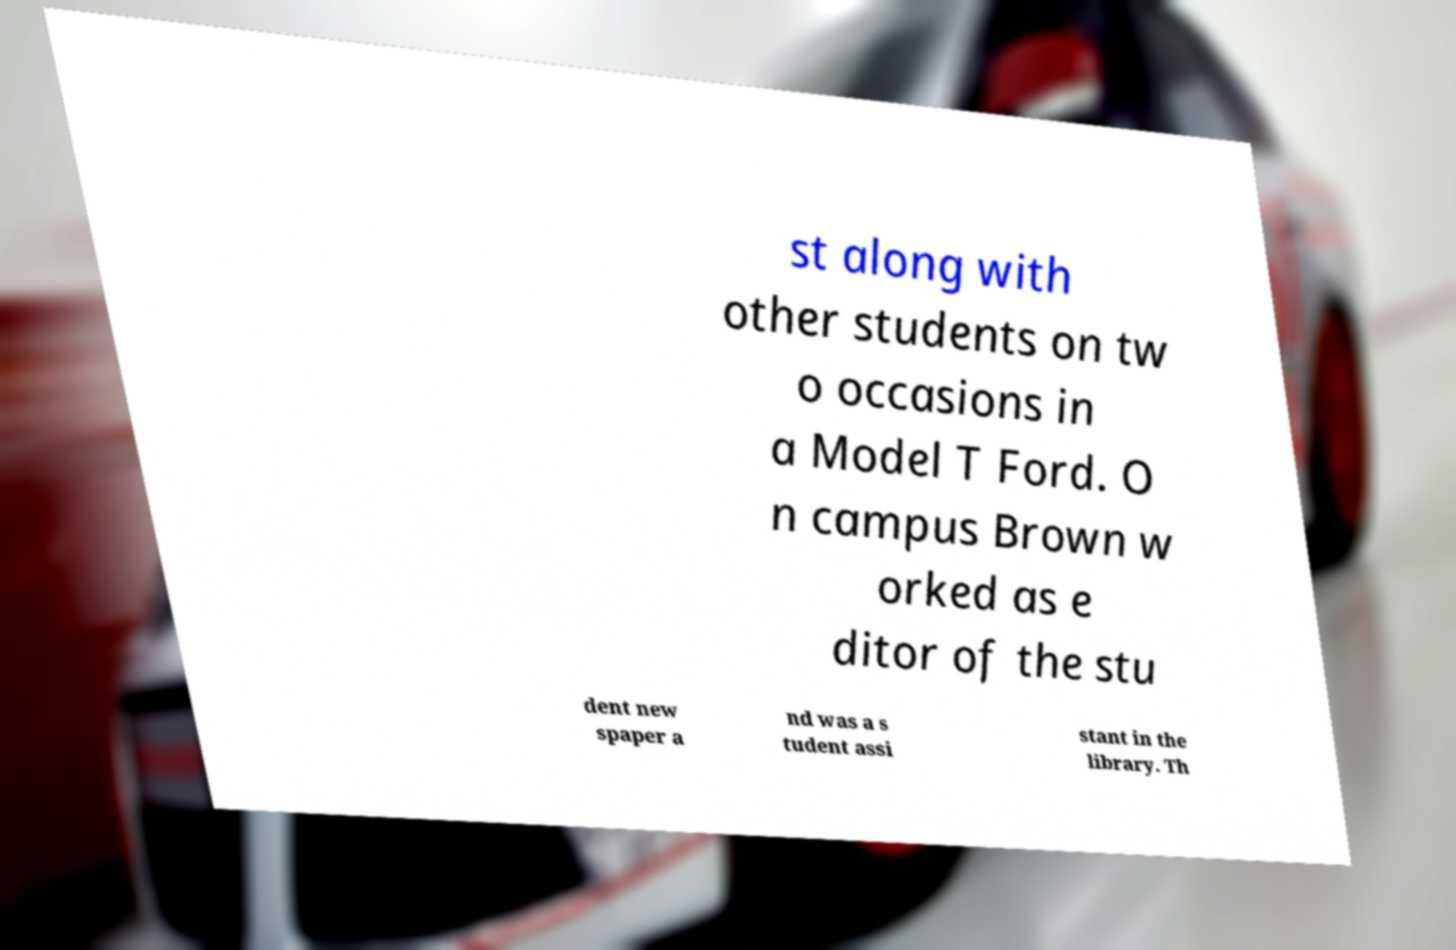What messages or text are displayed in this image? I need them in a readable, typed format. st along with other students on tw o occasions in a Model T Ford. O n campus Brown w orked as e ditor of the stu dent new spaper a nd was a s tudent assi stant in the library. Th 